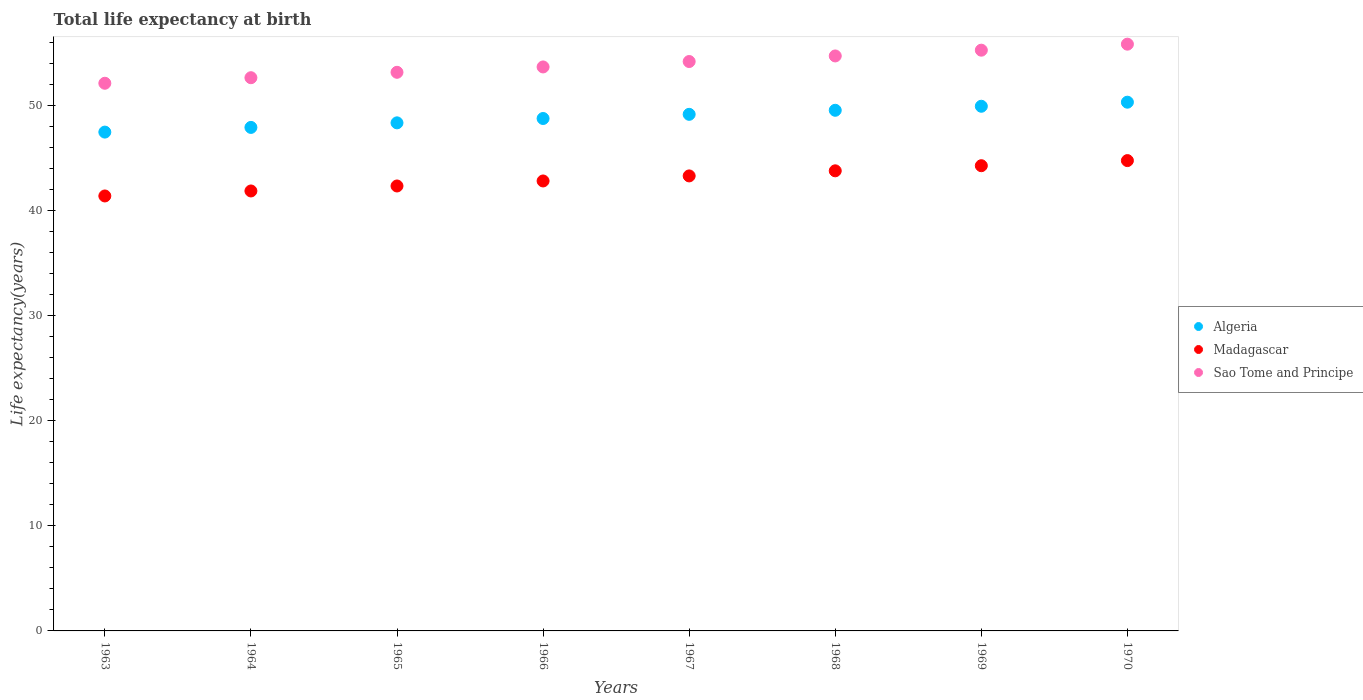How many different coloured dotlines are there?
Keep it short and to the point. 3. Is the number of dotlines equal to the number of legend labels?
Keep it short and to the point. Yes. What is the life expectancy at birth in in Algeria in 1970?
Your answer should be compact. 50.34. Across all years, what is the maximum life expectancy at birth in in Madagascar?
Provide a short and direct response. 44.78. Across all years, what is the minimum life expectancy at birth in in Algeria?
Your response must be concise. 47.5. What is the total life expectancy at birth in in Madagascar in the graph?
Ensure brevity in your answer.  344.72. What is the difference between the life expectancy at birth in in Madagascar in 1964 and that in 1967?
Offer a terse response. -1.43. What is the difference between the life expectancy at birth in in Sao Tome and Principe in 1968 and the life expectancy at birth in in Madagascar in 1963?
Your response must be concise. 13.33. What is the average life expectancy at birth in in Madagascar per year?
Offer a terse response. 43.09. In the year 1968, what is the difference between the life expectancy at birth in in Algeria and life expectancy at birth in in Madagascar?
Your response must be concise. 5.76. In how many years, is the life expectancy at birth in in Algeria greater than 46 years?
Your answer should be compact. 8. What is the ratio of the life expectancy at birth in in Madagascar in 1963 to that in 1964?
Your answer should be very brief. 0.99. Is the difference between the life expectancy at birth in in Algeria in 1966 and 1969 greater than the difference between the life expectancy at birth in in Madagascar in 1966 and 1969?
Provide a short and direct response. Yes. What is the difference between the highest and the second highest life expectancy at birth in in Algeria?
Give a very brief answer. 0.39. What is the difference between the highest and the lowest life expectancy at birth in in Algeria?
Offer a terse response. 2.85. Is it the case that in every year, the sum of the life expectancy at birth in in Sao Tome and Principe and life expectancy at birth in in Algeria  is greater than the life expectancy at birth in in Madagascar?
Give a very brief answer. Yes. Is the life expectancy at birth in in Sao Tome and Principe strictly less than the life expectancy at birth in in Algeria over the years?
Make the answer very short. No. How many dotlines are there?
Provide a short and direct response. 3. Does the graph contain grids?
Keep it short and to the point. No. How are the legend labels stacked?
Provide a short and direct response. Vertical. What is the title of the graph?
Make the answer very short. Total life expectancy at birth. Does "Russian Federation" appear as one of the legend labels in the graph?
Provide a short and direct response. No. What is the label or title of the X-axis?
Give a very brief answer. Years. What is the label or title of the Y-axis?
Provide a succinct answer. Life expectancy(years). What is the Life expectancy(years) of Algeria in 1963?
Your response must be concise. 47.5. What is the Life expectancy(years) in Madagascar in 1963?
Offer a terse response. 41.41. What is the Life expectancy(years) of Sao Tome and Principe in 1963?
Your answer should be compact. 52.15. What is the Life expectancy(years) in Algeria in 1964?
Make the answer very short. 47.94. What is the Life expectancy(years) in Madagascar in 1964?
Offer a very short reply. 41.89. What is the Life expectancy(years) in Sao Tome and Principe in 1964?
Your answer should be compact. 52.67. What is the Life expectancy(years) of Algeria in 1965?
Your answer should be very brief. 48.38. What is the Life expectancy(years) of Madagascar in 1965?
Your answer should be compact. 42.37. What is the Life expectancy(years) of Sao Tome and Principe in 1965?
Offer a very short reply. 53.19. What is the Life expectancy(years) of Algeria in 1966?
Give a very brief answer. 48.79. What is the Life expectancy(years) of Madagascar in 1966?
Keep it short and to the point. 42.84. What is the Life expectancy(years) of Sao Tome and Principe in 1966?
Offer a very short reply. 53.7. What is the Life expectancy(years) of Algeria in 1967?
Your answer should be very brief. 49.19. What is the Life expectancy(years) in Madagascar in 1967?
Give a very brief answer. 43.32. What is the Life expectancy(years) of Sao Tome and Principe in 1967?
Your answer should be compact. 54.22. What is the Life expectancy(years) in Algeria in 1968?
Give a very brief answer. 49.57. What is the Life expectancy(years) in Madagascar in 1968?
Make the answer very short. 43.81. What is the Life expectancy(years) of Sao Tome and Principe in 1968?
Offer a terse response. 54.75. What is the Life expectancy(years) of Algeria in 1969?
Provide a short and direct response. 49.96. What is the Life expectancy(years) in Madagascar in 1969?
Offer a very short reply. 44.3. What is the Life expectancy(years) in Sao Tome and Principe in 1969?
Give a very brief answer. 55.3. What is the Life expectancy(years) in Algeria in 1970?
Your response must be concise. 50.34. What is the Life expectancy(years) in Madagascar in 1970?
Provide a succinct answer. 44.78. What is the Life expectancy(years) of Sao Tome and Principe in 1970?
Offer a terse response. 55.87. Across all years, what is the maximum Life expectancy(years) in Algeria?
Provide a succinct answer. 50.34. Across all years, what is the maximum Life expectancy(years) in Madagascar?
Your answer should be compact. 44.78. Across all years, what is the maximum Life expectancy(years) of Sao Tome and Principe?
Offer a terse response. 55.87. Across all years, what is the minimum Life expectancy(years) of Algeria?
Keep it short and to the point. 47.5. Across all years, what is the minimum Life expectancy(years) of Madagascar?
Offer a very short reply. 41.41. Across all years, what is the minimum Life expectancy(years) of Sao Tome and Principe?
Provide a succinct answer. 52.15. What is the total Life expectancy(years) in Algeria in the graph?
Your answer should be very brief. 391.66. What is the total Life expectancy(years) of Madagascar in the graph?
Keep it short and to the point. 344.72. What is the total Life expectancy(years) in Sao Tome and Principe in the graph?
Your answer should be very brief. 431.84. What is the difference between the Life expectancy(years) in Algeria in 1963 and that in 1964?
Provide a short and direct response. -0.45. What is the difference between the Life expectancy(years) in Madagascar in 1963 and that in 1964?
Your answer should be very brief. -0.48. What is the difference between the Life expectancy(years) of Sao Tome and Principe in 1963 and that in 1964?
Give a very brief answer. -0.53. What is the difference between the Life expectancy(years) of Algeria in 1963 and that in 1965?
Your answer should be very brief. -0.88. What is the difference between the Life expectancy(years) of Madagascar in 1963 and that in 1965?
Offer a very short reply. -0.95. What is the difference between the Life expectancy(years) of Sao Tome and Principe in 1963 and that in 1965?
Provide a short and direct response. -1.04. What is the difference between the Life expectancy(years) of Algeria in 1963 and that in 1966?
Your answer should be very brief. -1.29. What is the difference between the Life expectancy(years) of Madagascar in 1963 and that in 1966?
Offer a terse response. -1.43. What is the difference between the Life expectancy(years) of Sao Tome and Principe in 1963 and that in 1966?
Keep it short and to the point. -1.55. What is the difference between the Life expectancy(years) in Algeria in 1963 and that in 1967?
Give a very brief answer. -1.69. What is the difference between the Life expectancy(years) of Madagascar in 1963 and that in 1967?
Give a very brief answer. -1.91. What is the difference between the Life expectancy(years) of Sao Tome and Principe in 1963 and that in 1967?
Offer a terse response. -2.07. What is the difference between the Life expectancy(years) in Algeria in 1963 and that in 1968?
Make the answer very short. -2.08. What is the difference between the Life expectancy(years) of Madagascar in 1963 and that in 1968?
Give a very brief answer. -2.39. What is the difference between the Life expectancy(years) of Sao Tome and Principe in 1963 and that in 1968?
Provide a succinct answer. -2.6. What is the difference between the Life expectancy(years) of Algeria in 1963 and that in 1969?
Offer a terse response. -2.46. What is the difference between the Life expectancy(years) of Madagascar in 1963 and that in 1969?
Provide a succinct answer. -2.88. What is the difference between the Life expectancy(years) in Sao Tome and Principe in 1963 and that in 1969?
Provide a short and direct response. -3.15. What is the difference between the Life expectancy(years) in Algeria in 1963 and that in 1970?
Your answer should be very brief. -2.85. What is the difference between the Life expectancy(years) of Madagascar in 1963 and that in 1970?
Provide a short and direct response. -3.37. What is the difference between the Life expectancy(years) in Sao Tome and Principe in 1963 and that in 1970?
Offer a terse response. -3.72. What is the difference between the Life expectancy(years) in Algeria in 1964 and that in 1965?
Offer a terse response. -0.43. What is the difference between the Life expectancy(years) in Madagascar in 1964 and that in 1965?
Your response must be concise. -0.48. What is the difference between the Life expectancy(years) of Sao Tome and Principe in 1964 and that in 1965?
Your response must be concise. -0.52. What is the difference between the Life expectancy(years) in Algeria in 1964 and that in 1966?
Ensure brevity in your answer.  -0.85. What is the difference between the Life expectancy(years) of Madagascar in 1964 and that in 1966?
Your answer should be compact. -0.95. What is the difference between the Life expectancy(years) in Sao Tome and Principe in 1964 and that in 1966?
Your answer should be compact. -1.02. What is the difference between the Life expectancy(years) of Algeria in 1964 and that in 1967?
Make the answer very short. -1.25. What is the difference between the Life expectancy(years) in Madagascar in 1964 and that in 1967?
Provide a short and direct response. -1.43. What is the difference between the Life expectancy(years) of Sao Tome and Principe in 1964 and that in 1967?
Give a very brief answer. -1.54. What is the difference between the Life expectancy(years) in Algeria in 1964 and that in 1968?
Your answer should be very brief. -1.63. What is the difference between the Life expectancy(years) in Madagascar in 1964 and that in 1968?
Ensure brevity in your answer.  -1.92. What is the difference between the Life expectancy(years) in Sao Tome and Principe in 1964 and that in 1968?
Your response must be concise. -2.07. What is the difference between the Life expectancy(years) of Algeria in 1964 and that in 1969?
Offer a very short reply. -2.01. What is the difference between the Life expectancy(years) in Madagascar in 1964 and that in 1969?
Ensure brevity in your answer.  -2.4. What is the difference between the Life expectancy(years) in Sao Tome and Principe in 1964 and that in 1969?
Provide a succinct answer. -2.62. What is the difference between the Life expectancy(years) of Algeria in 1964 and that in 1970?
Your answer should be very brief. -2.4. What is the difference between the Life expectancy(years) in Madagascar in 1964 and that in 1970?
Ensure brevity in your answer.  -2.89. What is the difference between the Life expectancy(years) of Sao Tome and Principe in 1964 and that in 1970?
Your response must be concise. -3.19. What is the difference between the Life expectancy(years) of Algeria in 1965 and that in 1966?
Provide a succinct answer. -0.41. What is the difference between the Life expectancy(years) in Madagascar in 1965 and that in 1966?
Provide a succinct answer. -0.48. What is the difference between the Life expectancy(years) in Sao Tome and Principe in 1965 and that in 1966?
Make the answer very short. -0.51. What is the difference between the Life expectancy(years) in Algeria in 1965 and that in 1967?
Ensure brevity in your answer.  -0.81. What is the difference between the Life expectancy(years) of Madagascar in 1965 and that in 1967?
Provide a short and direct response. -0.96. What is the difference between the Life expectancy(years) in Sao Tome and Principe in 1965 and that in 1967?
Offer a terse response. -1.03. What is the difference between the Life expectancy(years) in Algeria in 1965 and that in 1968?
Your answer should be very brief. -1.2. What is the difference between the Life expectancy(years) in Madagascar in 1965 and that in 1968?
Provide a succinct answer. -1.44. What is the difference between the Life expectancy(years) of Sao Tome and Principe in 1965 and that in 1968?
Give a very brief answer. -1.56. What is the difference between the Life expectancy(years) in Algeria in 1965 and that in 1969?
Provide a short and direct response. -1.58. What is the difference between the Life expectancy(years) of Madagascar in 1965 and that in 1969?
Keep it short and to the point. -1.93. What is the difference between the Life expectancy(years) in Sao Tome and Principe in 1965 and that in 1969?
Make the answer very short. -2.11. What is the difference between the Life expectancy(years) of Algeria in 1965 and that in 1970?
Keep it short and to the point. -1.97. What is the difference between the Life expectancy(years) of Madagascar in 1965 and that in 1970?
Offer a very short reply. -2.42. What is the difference between the Life expectancy(years) of Sao Tome and Principe in 1965 and that in 1970?
Make the answer very short. -2.68. What is the difference between the Life expectancy(years) of Algeria in 1966 and that in 1967?
Make the answer very short. -0.4. What is the difference between the Life expectancy(years) of Madagascar in 1966 and that in 1967?
Your answer should be very brief. -0.48. What is the difference between the Life expectancy(years) of Sao Tome and Principe in 1966 and that in 1967?
Give a very brief answer. -0.52. What is the difference between the Life expectancy(years) in Algeria in 1966 and that in 1968?
Offer a terse response. -0.78. What is the difference between the Life expectancy(years) of Madagascar in 1966 and that in 1968?
Offer a terse response. -0.97. What is the difference between the Life expectancy(years) in Sao Tome and Principe in 1966 and that in 1968?
Ensure brevity in your answer.  -1.05. What is the difference between the Life expectancy(years) in Algeria in 1966 and that in 1969?
Keep it short and to the point. -1.17. What is the difference between the Life expectancy(years) of Madagascar in 1966 and that in 1969?
Ensure brevity in your answer.  -1.45. What is the difference between the Life expectancy(years) in Sao Tome and Principe in 1966 and that in 1969?
Your answer should be compact. -1.6. What is the difference between the Life expectancy(years) in Algeria in 1966 and that in 1970?
Offer a very short reply. -1.55. What is the difference between the Life expectancy(years) of Madagascar in 1966 and that in 1970?
Offer a terse response. -1.94. What is the difference between the Life expectancy(years) of Sao Tome and Principe in 1966 and that in 1970?
Keep it short and to the point. -2.17. What is the difference between the Life expectancy(years) of Algeria in 1967 and that in 1968?
Your response must be concise. -0.39. What is the difference between the Life expectancy(years) of Madagascar in 1967 and that in 1968?
Provide a succinct answer. -0.48. What is the difference between the Life expectancy(years) of Sao Tome and Principe in 1967 and that in 1968?
Provide a succinct answer. -0.53. What is the difference between the Life expectancy(years) of Algeria in 1967 and that in 1969?
Give a very brief answer. -0.77. What is the difference between the Life expectancy(years) of Madagascar in 1967 and that in 1969?
Offer a terse response. -0.97. What is the difference between the Life expectancy(years) in Sao Tome and Principe in 1967 and that in 1969?
Keep it short and to the point. -1.08. What is the difference between the Life expectancy(years) in Algeria in 1967 and that in 1970?
Your response must be concise. -1.16. What is the difference between the Life expectancy(years) in Madagascar in 1967 and that in 1970?
Your response must be concise. -1.46. What is the difference between the Life expectancy(years) in Sao Tome and Principe in 1967 and that in 1970?
Make the answer very short. -1.65. What is the difference between the Life expectancy(years) in Algeria in 1968 and that in 1969?
Offer a very short reply. -0.38. What is the difference between the Life expectancy(years) in Madagascar in 1968 and that in 1969?
Your answer should be very brief. -0.49. What is the difference between the Life expectancy(years) of Sao Tome and Principe in 1968 and that in 1969?
Provide a succinct answer. -0.55. What is the difference between the Life expectancy(years) in Algeria in 1968 and that in 1970?
Ensure brevity in your answer.  -0.77. What is the difference between the Life expectancy(years) of Madagascar in 1968 and that in 1970?
Keep it short and to the point. -0.97. What is the difference between the Life expectancy(years) in Sao Tome and Principe in 1968 and that in 1970?
Provide a short and direct response. -1.12. What is the difference between the Life expectancy(years) of Algeria in 1969 and that in 1970?
Give a very brief answer. -0.39. What is the difference between the Life expectancy(years) of Madagascar in 1969 and that in 1970?
Provide a succinct answer. -0.49. What is the difference between the Life expectancy(years) of Sao Tome and Principe in 1969 and that in 1970?
Provide a succinct answer. -0.57. What is the difference between the Life expectancy(years) in Algeria in 1963 and the Life expectancy(years) in Madagascar in 1964?
Offer a very short reply. 5.61. What is the difference between the Life expectancy(years) of Algeria in 1963 and the Life expectancy(years) of Sao Tome and Principe in 1964?
Provide a short and direct response. -5.18. What is the difference between the Life expectancy(years) of Madagascar in 1963 and the Life expectancy(years) of Sao Tome and Principe in 1964?
Keep it short and to the point. -11.26. What is the difference between the Life expectancy(years) in Algeria in 1963 and the Life expectancy(years) in Madagascar in 1965?
Provide a short and direct response. 5.13. What is the difference between the Life expectancy(years) in Algeria in 1963 and the Life expectancy(years) in Sao Tome and Principe in 1965?
Provide a succinct answer. -5.69. What is the difference between the Life expectancy(years) of Madagascar in 1963 and the Life expectancy(years) of Sao Tome and Principe in 1965?
Your answer should be very brief. -11.77. What is the difference between the Life expectancy(years) of Algeria in 1963 and the Life expectancy(years) of Madagascar in 1966?
Offer a very short reply. 4.65. What is the difference between the Life expectancy(years) in Algeria in 1963 and the Life expectancy(years) in Sao Tome and Principe in 1966?
Your response must be concise. -6.2. What is the difference between the Life expectancy(years) in Madagascar in 1963 and the Life expectancy(years) in Sao Tome and Principe in 1966?
Your answer should be compact. -12.28. What is the difference between the Life expectancy(years) of Algeria in 1963 and the Life expectancy(years) of Madagascar in 1967?
Your response must be concise. 4.17. What is the difference between the Life expectancy(years) in Algeria in 1963 and the Life expectancy(years) in Sao Tome and Principe in 1967?
Give a very brief answer. -6.72. What is the difference between the Life expectancy(years) of Madagascar in 1963 and the Life expectancy(years) of Sao Tome and Principe in 1967?
Offer a very short reply. -12.8. What is the difference between the Life expectancy(years) in Algeria in 1963 and the Life expectancy(years) in Madagascar in 1968?
Your answer should be very brief. 3.69. What is the difference between the Life expectancy(years) of Algeria in 1963 and the Life expectancy(years) of Sao Tome and Principe in 1968?
Your answer should be compact. -7.25. What is the difference between the Life expectancy(years) of Madagascar in 1963 and the Life expectancy(years) of Sao Tome and Principe in 1968?
Your answer should be very brief. -13.33. What is the difference between the Life expectancy(years) in Algeria in 1963 and the Life expectancy(years) in Madagascar in 1969?
Your answer should be compact. 3.2. What is the difference between the Life expectancy(years) of Algeria in 1963 and the Life expectancy(years) of Sao Tome and Principe in 1969?
Your response must be concise. -7.8. What is the difference between the Life expectancy(years) in Madagascar in 1963 and the Life expectancy(years) in Sao Tome and Principe in 1969?
Provide a succinct answer. -13.88. What is the difference between the Life expectancy(years) of Algeria in 1963 and the Life expectancy(years) of Madagascar in 1970?
Offer a very short reply. 2.71. What is the difference between the Life expectancy(years) in Algeria in 1963 and the Life expectancy(years) in Sao Tome and Principe in 1970?
Offer a very short reply. -8.37. What is the difference between the Life expectancy(years) in Madagascar in 1963 and the Life expectancy(years) in Sao Tome and Principe in 1970?
Your response must be concise. -14.45. What is the difference between the Life expectancy(years) in Algeria in 1964 and the Life expectancy(years) in Madagascar in 1965?
Provide a short and direct response. 5.58. What is the difference between the Life expectancy(years) of Algeria in 1964 and the Life expectancy(years) of Sao Tome and Principe in 1965?
Provide a short and direct response. -5.25. What is the difference between the Life expectancy(years) of Madagascar in 1964 and the Life expectancy(years) of Sao Tome and Principe in 1965?
Offer a very short reply. -11.3. What is the difference between the Life expectancy(years) of Algeria in 1964 and the Life expectancy(years) of Madagascar in 1966?
Provide a short and direct response. 5.1. What is the difference between the Life expectancy(years) of Algeria in 1964 and the Life expectancy(years) of Sao Tome and Principe in 1966?
Keep it short and to the point. -5.76. What is the difference between the Life expectancy(years) of Madagascar in 1964 and the Life expectancy(years) of Sao Tome and Principe in 1966?
Keep it short and to the point. -11.81. What is the difference between the Life expectancy(years) of Algeria in 1964 and the Life expectancy(years) of Madagascar in 1967?
Your answer should be compact. 4.62. What is the difference between the Life expectancy(years) in Algeria in 1964 and the Life expectancy(years) in Sao Tome and Principe in 1967?
Your answer should be compact. -6.27. What is the difference between the Life expectancy(years) in Madagascar in 1964 and the Life expectancy(years) in Sao Tome and Principe in 1967?
Ensure brevity in your answer.  -12.33. What is the difference between the Life expectancy(years) in Algeria in 1964 and the Life expectancy(years) in Madagascar in 1968?
Make the answer very short. 4.13. What is the difference between the Life expectancy(years) in Algeria in 1964 and the Life expectancy(years) in Sao Tome and Principe in 1968?
Provide a succinct answer. -6.81. What is the difference between the Life expectancy(years) of Madagascar in 1964 and the Life expectancy(years) of Sao Tome and Principe in 1968?
Your answer should be compact. -12.86. What is the difference between the Life expectancy(years) in Algeria in 1964 and the Life expectancy(years) in Madagascar in 1969?
Offer a very short reply. 3.65. What is the difference between the Life expectancy(years) in Algeria in 1964 and the Life expectancy(years) in Sao Tome and Principe in 1969?
Offer a very short reply. -7.35. What is the difference between the Life expectancy(years) in Madagascar in 1964 and the Life expectancy(years) in Sao Tome and Principe in 1969?
Offer a very short reply. -13.41. What is the difference between the Life expectancy(years) of Algeria in 1964 and the Life expectancy(years) of Madagascar in 1970?
Keep it short and to the point. 3.16. What is the difference between the Life expectancy(years) in Algeria in 1964 and the Life expectancy(years) in Sao Tome and Principe in 1970?
Provide a succinct answer. -7.93. What is the difference between the Life expectancy(years) in Madagascar in 1964 and the Life expectancy(years) in Sao Tome and Principe in 1970?
Your answer should be very brief. -13.98. What is the difference between the Life expectancy(years) of Algeria in 1965 and the Life expectancy(years) of Madagascar in 1966?
Offer a terse response. 5.53. What is the difference between the Life expectancy(years) in Algeria in 1965 and the Life expectancy(years) in Sao Tome and Principe in 1966?
Keep it short and to the point. -5.32. What is the difference between the Life expectancy(years) of Madagascar in 1965 and the Life expectancy(years) of Sao Tome and Principe in 1966?
Offer a terse response. -11.33. What is the difference between the Life expectancy(years) of Algeria in 1965 and the Life expectancy(years) of Madagascar in 1967?
Offer a very short reply. 5.05. What is the difference between the Life expectancy(years) of Algeria in 1965 and the Life expectancy(years) of Sao Tome and Principe in 1967?
Your answer should be very brief. -5.84. What is the difference between the Life expectancy(years) in Madagascar in 1965 and the Life expectancy(years) in Sao Tome and Principe in 1967?
Make the answer very short. -11.85. What is the difference between the Life expectancy(years) of Algeria in 1965 and the Life expectancy(years) of Madagascar in 1968?
Your answer should be compact. 4.57. What is the difference between the Life expectancy(years) in Algeria in 1965 and the Life expectancy(years) in Sao Tome and Principe in 1968?
Give a very brief answer. -6.37. What is the difference between the Life expectancy(years) of Madagascar in 1965 and the Life expectancy(years) of Sao Tome and Principe in 1968?
Your answer should be compact. -12.38. What is the difference between the Life expectancy(years) in Algeria in 1965 and the Life expectancy(years) in Madagascar in 1969?
Ensure brevity in your answer.  4.08. What is the difference between the Life expectancy(years) of Algeria in 1965 and the Life expectancy(years) of Sao Tome and Principe in 1969?
Your answer should be very brief. -6.92. What is the difference between the Life expectancy(years) in Madagascar in 1965 and the Life expectancy(years) in Sao Tome and Principe in 1969?
Offer a very short reply. -12.93. What is the difference between the Life expectancy(years) in Algeria in 1965 and the Life expectancy(years) in Madagascar in 1970?
Ensure brevity in your answer.  3.59. What is the difference between the Life expectancy(years) in Algeria in 1965 and the Life expectancy(years) in Sao Tome and Principe in 1970?
Your answer should be compact. -7.49. What is the difference between the Life expectancy(years) of Madagascar in 1965 and the Life expectancy(years) of Sao Tome and Principe in 1970?
Offer a terse response. -13.5. What is the difference between the Life expectancy(years) in Algeria in 1966 and the Life expectancy(years) in Madagascar in 1967?
Give a very brief answer. 5.47. What is the difference between the Life expectancy(years) in Algeria in 1966 and the Life expectancy(years) in Sao Tome and Principe in 1967?
Provide a succinct answer. -5.42. What is the difference between the Life expectancy(years) in Madagascar in 1966 and the Life expectancy(years) in Sao Tome and Principe in 1967?
Give a very brief answer. -11.37. What is the difference between the Life expectancy(years) in Algeria in 1966 and the Life expectancy(years) in Madagascar in 1968?
Offer a terse response. 4.98. What is the difference between the Life expectancy(years) of Algeria in 1966 and the Life expectancy(years) of Sao Tome and Principe in 1968?
Give a very brief answer. -5.96. What is the difference between the Life expectancy(years) of Madagascar in 1966 and the Life expectancy(years) of Sao Tome and Principe in 1968?
Your answer should be very brief. -11.9. What is the difference between the Life expectancy(years) in Algeria in 1966 and the Life expectancy(years) in Madagascar in 1969?
Your answer should be very brief. 4.5. What is the difference between the Life expectancy(years) in Algeria in 1966 and the Life expectancy(years) in Sao Tome and Principe in 1969?
Keep it short and to the point. -6.51. What is the difference between the Life expectancy(years) in Madagascar in 1966 and the Life expectancy(years) in Sao Tome and Principe in 1969?
Your answer should be compact. -12.45. What is the difference between the Life expectancy(years) in Algeria in 1966 and the Life expectancy(years) in Madagascar in 1970?
Your answer should be very brief. 4.01. What is the difference between the Life expectancy(years) in Algeria in 1966 and the Life expectancy(years) in Sao Tome and Principe in 1970?
Provide a succinct answer. -7.08. What is the difference between the Life expectancy(years) of Madagascar in 1966 and the Life expectancy(years) of Sao Tome and Principe in 1970?
Provide a short and direct response. -13.03. What is the difference between the Life expectancy(years) in Algeria in 1967 and the Life expectancy(years) in Madagascar in 1968?
Keep it short and to the point. 5.38. What is the difference between the Life expectancy(years) in Algeria in 1967 and the Life expectancy(years) in Sao Tome and Principe in 1968?
Keep it short and to the point. -5.56. What is the difference between the Life expectancy(years) in Madagascar in 1967 and the Life expectancy(years) in Sao Tome and Principe in 1968?
Give a very brief answer. -11.42. What is the difference between the Life expectancy(years) of Algeria in 1967 and the Life expectancy(years) of Madagascar in 1969?
Your response must be concise. 4.89. What is the difference between the Life expectancy(years) of Algeria in 1967 and the Life expectancy(years) of Sao Tome and Principe in 1969?
Give a very brief answer. -6.11. What is the difference between the Life expectancy(years) in Madagascar in 1967 and the Life expectancy(years) in Sao Tome and Principe in 1969?
Provide a succinct answer. -11.97. What is the difference between the Life expectancy(years) of Algeria in 1967 and the Life expectancy(years) of Madagascar in 1970?
Keep it short and to the point. 4.41. What is the difference between the Life expectancy(years) in Algeria in 1967 and the Life expectancy(years) in Sao Tome and Principe in 1970?
Your answer should be compact. -6.68. What is the difference between the Life expectancy(years) in Madagascar in 1967 and the Life expectancy(years) in Sao Tome and Principe in 1970?
Give a very brief answer. -12.54. What is the difference between the Life expectancy(years) of Algeria in 1968 and the Life expectancy(years) of Madagascar in 1969?
Keep it short and to the point. 5.28. What is the difference between the Life expectancy(years) in Algeria in 1968 and the Life expectancy(years) in Sao Tome and Principe in 1969?
Give a very brief answer. -5.72. What is the difference between the Life expectancy(years) of Madagascar in 1968 and the Life expectancy(years) of Sao Tome and Principe in 1969?
Your answer should be compact. -11.49. What is the difference between the Life expectancy(years) of Algeria in 1968 and the Life expectancy(years) of Madagascar in 1970?
Offer a very short reply. 4.79. What is the difference between the Life expectancy(years) in Algeria in 1968 and the Life expectancy(years) in Sao Tome and Principe in 1970?
Make the answer very short. -6.3. What is the difference between the Life expectancy(years) in Madagascar in 1968 and the Life expectancy(years) in Sao Tome and Principe in 1970?
Your answer should be very brief. -12.06. What is the difference between the Life expectancy(years) of Algeria in 1969 and the Life expectancy(years) of Madagascar in 1970?
Offer a very short reply. 5.17. What is the difference between the Life expectancy(years) in Algeria in 1969 and the Life expectancy(years) in Sao Tome and Principe in 1970?
Your answer should be very brief. -5.91. What is the difference between the Life expectancy(years) in Madagascar in 1969 and the Life expectancy(years) in Sao Tome and Principe in 1970?
Your answer should be very brief. -11.57. What is the average Life expectancy(years) of Algeria per year?
Keep it short and to the point. 48.96. What is the average Life expectancy(years) in Madagascar per year?
Provide a succinct answer. 43.09. What is the average Life expectancy(years) in Sao Tome and Principe per year?
Provide a succinct answer. 53.98. In the year 1963, what is the difference between the Life expectancy(years) in Algeria and Life expectancy(years) in Madagascar?
Provide a short and direct response. 6.08. In the year 1963, what is the difference between the Life expectancy(years) of Algeria and Life expectancy(years) of Sao Tome and Principe?
Your answer should be compact. -4.65. In the year 1963, what is the difference between the Life expectancy(years) of Madagascar and Life expectancy(years) of Sao Tome and Principe?
Offer a terse response. -10.73. In the year 1964, what is the difference between the Life expectancy(years) in Algeria and Life expectancy(years) in Madagascar?
Offer a very short reply. 6.05. In the year 1964, what is the difference between the Life expectancy(years) in Algeria and Life expectancy(years) in Sao Tome and Principe?
Give a very brief answer. -4.73. In the year 1964, what is the difference between the Life expectancy(years) in Madagascar and Life expectancy(years) in Sao Tome and Principe?
Provide a succinct answer. -10.78. In the year 1965, what is the difference between the Life expectancy(years) of Algeria and Life expectancy(years) of Madagascar?
Your answer should be compact. 6.01. In the year 1965, what is the difference between the Life expectancy(years) in Algeria and Life expectancy(years) in Sao Tome and Principe?
Keep it short and to the point. -4.81. In the year 1965, what is the difference between the Life expectancy(years) of Madagascar and Life expectancy(years) of Sao Tome and Principe?
Your response must be concise. -10.82. In the year 1966, what is the difference between the Life expectancy(years) of Algeria and Life expectancy(years) of Madagascar?
Provide a short and direct response. 5.95. In the year 1966, what is the difference between the Life expectancy(years) of Algeria and Life expectancy(years) of Sao Tome and Principe?
Make the answer very short. -4.91. In the year 1966, what is the difference between the Life expectancy(years) in Madagascar and Life expectancy(years) in Sao Tome and Principe?
Give a very brief answer. -10.86. In the year 1967, what is the difference between the Life expectancy(years) in Algeria and Life expectancy(years) in Madagascar?
Keep it short and to the point. 5.86. In the year 1967, what is the difference between the Life expectancy(years) of Algeria and Life expectancy(years) of Sao Tome and Principe?
Your response must be concise. -5.03. In the year 1967, what is the difference between the Life expectancy(years) in Madagascar and Life expectancy(years) in Sao Tome and Principe?
Offer a very short reply. -10.89. In the year 1968, what is the difference between the Life expectancy(years) in Algeria and Life expectancy(years) in Madagascar?
Ensure brevity in your answer.  5.76. In the year 1968, what is the difference between the Life expectancy(years) in Algeria and Life expectancy(years) in Sao Tome and Principe?
Give a very brief answer. -5.17. In the year 1968, what is the difference between the Life expectancy(years) in Madagascar and Life expectancy(years) in Sao Tome and Principe?
Give a very brief answer. -10.94. In the year 1969, what is the difference between the Life expectancy(years) in Algeria and Life expectancy(years) in Madagascar?
Provide a short and direct response. 5.66. In the year 1969, what is the difference between the Life expectancy(years) in Algeria and Life expectancy(years) in Sao Tome and Principe?
Your answer should be very brief. -5.34. In the year 1969, what is the difference between the Life expectancy(years) in Madagascar and Life expectancy(years) in Sao Tome and Principe?
Offer a very short reply. -11. In the year 1970, what is the difference between the Life expectancy(years) in Algeria and Life expectancy(years) in Madagascar?
Provide a succinct answer. 5.56. In the year 1970, what is the difference between the Life expectancy(years) of Algeria and Life expectancy(years) of Sao Tome and Principe?
Ensure brevity in your answer.  -5.52. In the year 1970, what is the difference between the Life expectancy(years) in Madagascar and Life expectancy(years) in Sao Tome and Principe?
Make the answer very short. -11.09. What is the ratio of the Life expectancy(years) of Sao Tome and Principe in 1963 to that in 1964?
Ensure brevity in your answer.  0.99. What is the ratio of the Life expectancy(years) of Algeria in 1963 to that in 1965?
Give a very brief answer. 0.98. What is the ratio of the Life expectancy(years) of Madagascar in 1963 to that in 1965?
Your answer should be compact. 0.98. What is the ratio of the Life expectancy(years) of Sao Tome and Principe in 1963 to that in 1965?
Provide a short and direct response. 0.98. What is the ratio of the Life expectancy(years) in Algeria in 1963 to that in 1966?
Offer a terse response. 0.97. What is the ratio of the Life expectancy(years) of Madagascar in 1963 to that in 1966?
Ensure brevity in your answer.  0.97. What is the ratio of the Life expectancy(years) of Sao Tome and Principe in 1963 to that in 1966?
Ensure brevity in your answer.  0.97. What is the ratio of the Life expectancy(years) in Algeria in 1963 to that in 1967?
Keep it short and to the point. 0.97. What is the ratio of the Life expectancy(years) in Madagascar in 1963 to that in 1967?
Your answer should be compact. 0.96. What is the ratio of the Life expectancy(years) of Sao Tome and Principe in 1963 to that in 1967?
Offer a terse response. 0.96. What is the ratio of the Life expectancy(years) in Algeria in 1963 to that in 1968?
Offer a terse response. 0.96. What is the ratio of the Life expectancy(years) in Madagascar in 1963 to that in 1968?
Provide a short and direct response. 0.95. What is the ratio of the Life expectancy(years) in Sao Tome and Principe in 1963 to that in 1968?
Your response must be concise. 0.95. What is the ratio of the Life expectancy(years) in Algeria in 1963 to that in 1969?
Give a very brief answer. 0.95. What is the ratio of the Life expectancy(years) of Madagascar in 1963 to that in 1969?
Your answer should be very brief. 0.94. What is the ratio of the Life expectancy(years) of Sao Tome and Principe in 1963 to that in 1969?
Give a very brief answer. 0.94. What is the ratio of the Life expectancy(years) of Algeria in 1963 to that in 1970?
Your answer should be very brief. 0.94. What is the ratio of the Life expectancy(years) of Madagascar in 1963 to that in 1970?
Make the answer very short. 0.92. What is the ratio of the Life expectancy(years) in Sao Tome and Principe in 1963 to that in 1970?
Provide a succinct answer. 0.93. What is the ratio of the Life expectancy(years) of Sao Tome and Principe in 1964 to that in 1965?
Your response must be concise. 0.99. What is the ratio of the Life expectancy(years) of Algeria in 1964 to that in 1966?
Offer a very short reply. 0.98. What is the ratio of the Life expectancy(years) in Madagascar in 1964 to that in 1966?
Your answer should be compact. 0.98. What is the ratio of the Life expectancy(years) in Sao Tome and Principe in 1964 to that in 1966?
Provide a succinct answer. 0.98. What is the ratio of the Life expectancy(years) of Algeria in 1964 to that in 1967?
Ensure brevity in your answer.  0.97. What is the ratio of the Life expectancy(years) in Madagascar in 1964 to that in 1967?
Provide a succinct answer. 0.97. What is the ratio of the Life expectancy(years) in Sao Tome and Principe in 1964 to that in 1967?
Your answer should be compact. 0.97. What is the ratio of the Life expectancy(years) in Algeria in 1964 to that in 1968?
Keep it short and to the point. 0.97. What is the ratio of the Life expectancy(years) of Madagascar in 1964 to that in 1968?
Ensure brevity in your answer.  0.96. What is the ratio of the Life expectancy(years) in Sao Tome and Principe in 1964 to that in 1968?
Offer a very short reply. 0.96. What is the ratio of the Life expectancy(years) of Algeria in 1964 to that in 1969?
Ensure brevity in your answer.  0.96. What is the ratio of the Life expectancy(years) of Madagascar in 1964 to that in 1969?
Give a very brief answer. 0.95. What is the ratio of the Life expectancy(years) of Sao Tome and Principe in 1964 to that in 1969?
Ensure brevity in your answer.  0.95. What is the ratio of the Life expectancy(years) of Algeria in 1964 to that in 1970?
Give a very brief answer. 0.95. What is the ratio of the Life expectancy(years) in Madagascar in 1964 to that in 1970?
Provide a succinct answer. 0.94. What is the ratio of the Life expectancy(years) in Sao Tome and Principe in 1964 to that in 1970?
Your response must be concise. 0.94. What is the ratio of the Life expectancy(years) in Madagascar in 1965 to that in 1966?
Offer a terse response. 0.99. What is the ratio of the Life expectancy(years) in Algeria in 1965 to that in 1967?
Your response must be concise. 0.98. What is the ratio of the Life expectancy(years) of Madagascar in 1965 to that in 1967?
Your answer should be very brief. 0.98. What is the ratio of the Life expectancy(years) in Sao Tome and Principe in 1965 to that in 1967?
Offer a very short reply. 0.98. What is the ratio of the Life expectancy(years) of Algeria in 1965 to that in 1968?
Provide a succinct answer. 0.98. What is the ratio of the Life expectancy(years) of Madagascar in 1965 to that in 1968?
Give a very brief answer. 0.97. What is the ratio of the Life expectancy(years) in Sao Tome and Principe in 1965 to that in 1968?
Ensure brevity in your answer.  0.97. What is the ratio of the Life expectancy(years) of Algeria in 1965 to that in 1969?
Give a very brief answer. 0.97. What is the ratio of the Life expectancy(years) of Madagascar in 1965 to that in 1969?
Your answer should be compact. 0.96. What is the ratio of the Life expectancy(years) of Sao Tome and Principe in 1965 to that in 1969?
Keep it short and to the point. 0.96. What is the ratio of the Life expectancy(years) of Algeria in 1965 to that in 1970?
Offer a terse response. 0.96. What is the ratio of the Life expectancy(years) of Madagascar in 1965 to that in 1970?
Provide a short and direct response. 0.95. What is the ratio of the Life expectancy(years) in Sao Tome and Principe in 1965 to that in 1970?
Offer a very short reply. 0.95. What is the ratio of the Life expectancy(years) of Madagascar in 1966 to that in 1967?
Your answer should be compact. 0.99. What is the ratio of the Life expectancy(years) in Algeria in 1966 to that in 1968?
Provide a short and direct response. 0.98. What is the ratio of the Life expectancy(years) in Madagascar in 1966 to that in 1968?
Offer a terse response. 0.98. What is the ratio of the Life expectancy(years) in Sao Tome and Principe in 1966 to that in 1968?
Your answer should be very brief. 0.98. What is the ratio of the Life expectancy(years) of Algeria in 1966 to that in 1969?
Keep it short and to the point. 0.98. What is the ratio of the Life expectancy(years) of Madagascar in 1966 to that in 1969?
Your response must be concise. 0.97. What is the ratio of the Life expectancy(years) of Sao Tome and Principe in 1966 to that in 1969?
Provide a succinct answer. 0.97. What is the ratio of the Life expectancy(years) of Algeria in 1966 to that in 1970?
Give a very brief answer. 0.97. What is the ratio of the Life expectancy(years) in Madagascar in 1966 to that in 1970?
Offer a terse response. 0.96. What is the ratio of the Life expectancy(years) in Sao Tome and Principe in 1966 to that in 1970?
Give a very brief answer. 0.96. What is the ratio of the Life expectancy(years) in Madagascar in 1967 to that in 1968?
Offer a terse response. 0.99. What is the ratio of the Life expectancy(years) in Sao Tome and Principe in 1967 to that in 1968?
Your answer should be very brief. 0.99. What is the ratio of the Life expectancy(years) in Algeria in 1967 to that in 1969?
Your answer should be compact. 0.98. What is the ratio of the Life expectancy(years) of Madagascar in 1967 to that in 1969?
Your answer should be compact. 0.98. What is the ratio of the Life expectancy(years) in Sao Tome and Principe in 1967 to that in 1969?
Make the answer very short. 0.98. What is the ratio of the Life expectancy(years) in Madagascar in 1967 to that in 1970?
Offer a terse response. 0.97. What is the ratio of the Life expectancy(years) of Sao Tome and Principe in 1967 to that in 1970?
Provide a succinct answer. 0.97. What is the ratio of the Life expectancy(years) in Algeria in 1968 to that in 1969?
Keep it short and to the point. 0.99. What is the ratio of the Life expectancy(years) of Madagascar in 1968 to that in 1969?
Ensure brevity in your answer.  0.99. What is the ratio of the Life expectancy(years) of Sao Tome and Principe in 1968 to that in 1969?
Make the answer very short. 0.99. What is the ratio of the Life expectancy(years) of Algeria in 1968 to that in 1970?
Ensure brevity in your answer.  0.98. What is the ratio of the Life expectancy(years) of Madagascar in 1968 to that in 1970?
Your response must be concise. 0.98. What is the ratio of the Life expectancy(years) in Sao Tome and Principe in 1968 to that in 1970?
Make the answer very short. 0.98. What is the ratio of the Life expectancy(years) of Algeria in 1969 to that in 1970?
Ensure brevity in your answer.  0.99. What is the ratio of the Life expectancy(years) in Madagascar in 1969 to that in 1970?
Ensure brevity in your answer.  0.99. What is the difference between the highest and the second highest Life expectancy(years) in Algeria?
Your answer should be very brief. 0.39. What is the difference between the highest and the second highest Life expectancy(years) of Madagascar?
Your response must be concise. 0.49. What is the difference between the highest and the second highest Life expectancy(years) in Sao Tome and Principe?
Offer a very short reply. 0.57. What is the difference between the highest and the lowest Life expectancy(years) of Algeria?
Make the answer very short. 2.85. What is the difference between the highest and the lowest Life expectancy(years) of Madagascar?
Ensure brevity in your answer.  3.37. What is the difference between the highest and the lowest Life expectancy(years) of Sao Tome and Principe?
Ensure brevity in your answer.  3.72. 